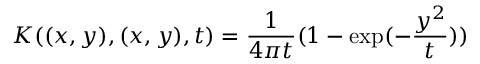Convert formula to latex. <formula><loc_0><loc_0><loc_500><loc_500>K ( ( x , y ) , ( x , y ) , t ) = { \frac { 1 } { 4 \pi t } } ( 1 - \exp ( - { \frac { y ^ { 2 } } { t } } ) )</formula> 